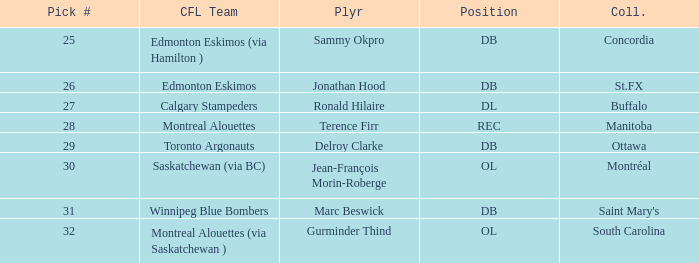Which College has a Position of ol, and a Pick # smaller than 32? Montréal. 